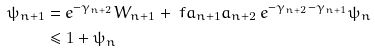<formula> <loc_0><loc_0><loc_500><loc_500>\psi _ { n + 1 } & = e ^ { - \gamma _ { n + 2 } } W _ { n + 1 } + \ f { a _ { n + 1 } } { a _ { n + 2 } } \, e ^ { - \gamma _ { n + 2 } - \gamma _ { n + 1 } } \psi _ { n } \\ & \leq 1 + \psi _ { n }</formula> 